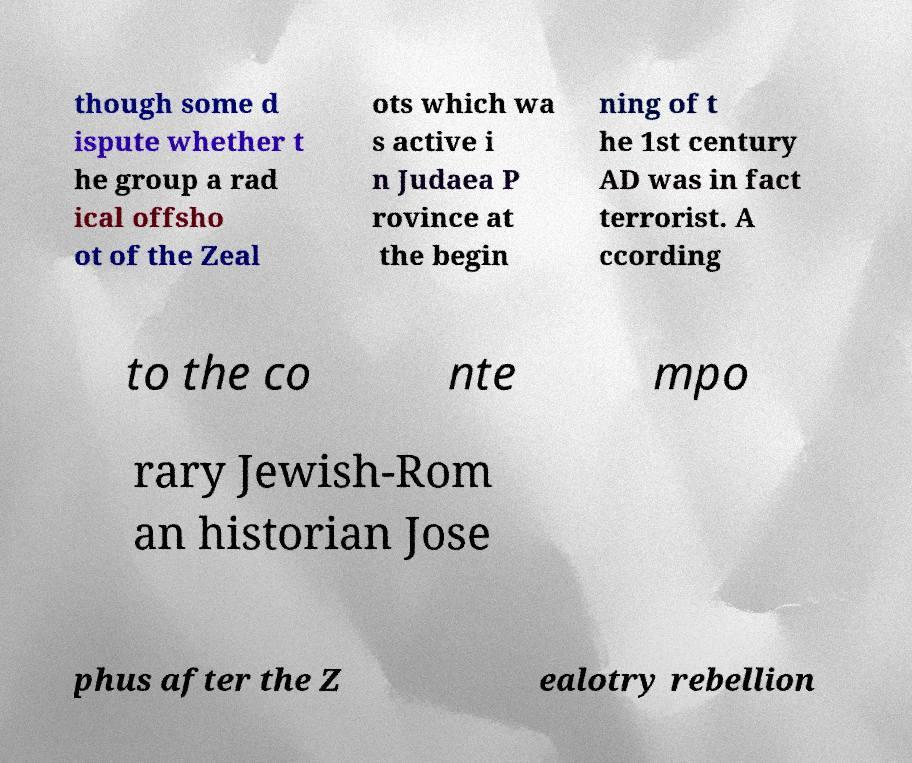I need the written content from this picture converted into text. Can you do that? though some d ispute whether t he group a rad ical offsho ot of the Zeal ots which wa s active i n Judaea P rovince at the begin ning of t he 1st century AD was in fact terrorist. A ccording to the co nte mpo rary Jewish-Rom an historian Jose phus after the Z ealotry rebellion 